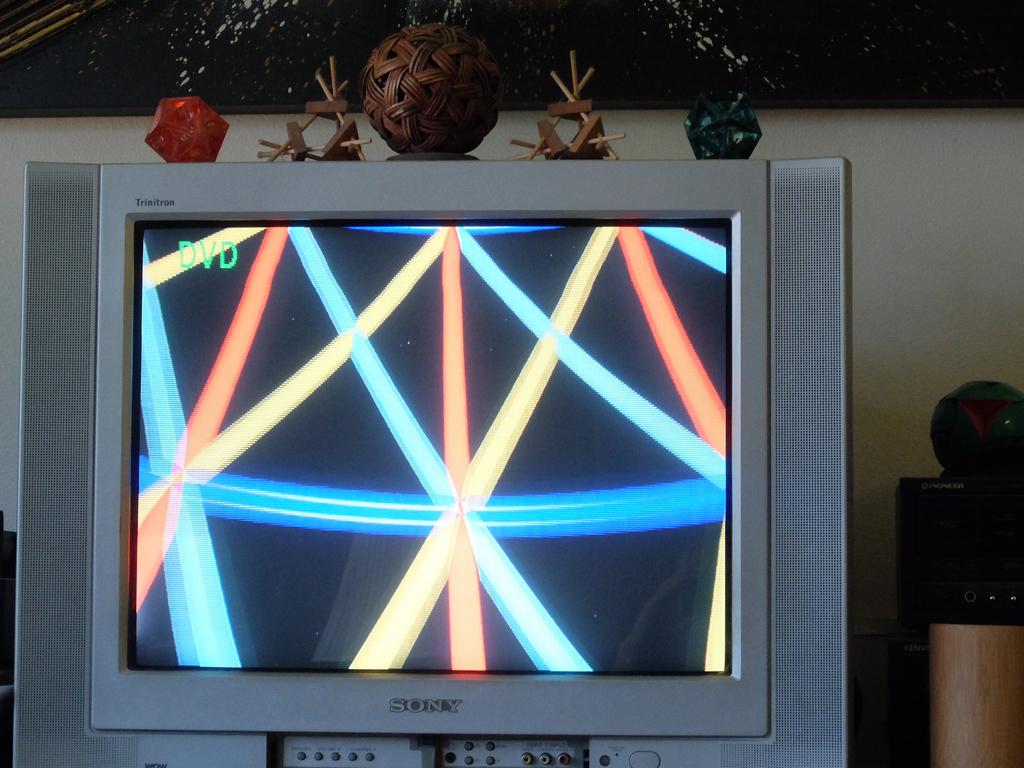What brand is this tv?
Offer a terse response. Sony. Does it say dvd at the top left?
Offer a terse response. Yes. 